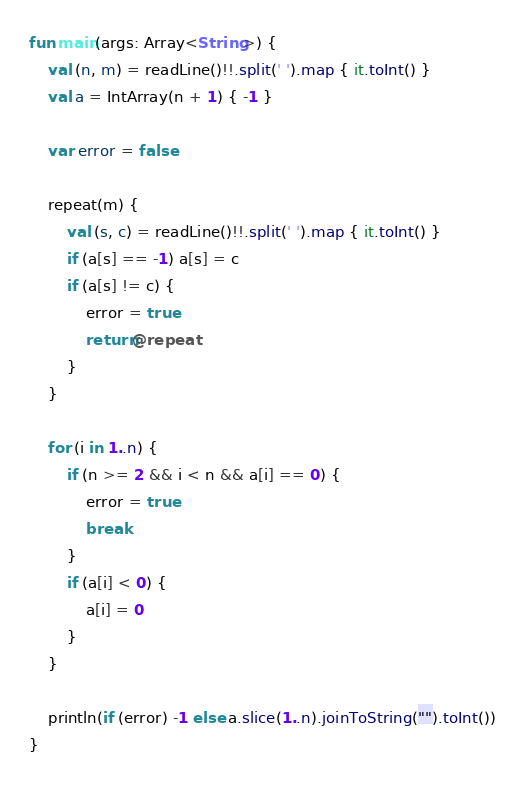Convert code to text. <code><loc_0><loc_0><loc_500><loc_500><_Kotlin_>fun main(args: Array<String>) {
    val (n, m) = readLine()!!.split(' ').map { it.toInt() }
    val a = IntArray(n + 1) { -1 }

    var error = false

    repeat(m) {
        val (s, c) = readLine()!!.split(' ').map { it.toInt() }
        if (a[s] == -1) a[s] = c
        if (a[s] != c) {
            error = true
            return@repeat
        }
    }

    for (i in 1..n) {
        if (n >= 2 && i < n && a[i] == 0) {
            error = true
            break
        }
        if (a[i] < 0) {
            a[i] = 0
        }
    }

    println(if (error) -1 else a.slice(1..n).joinToString("").toInt())
}</code> 